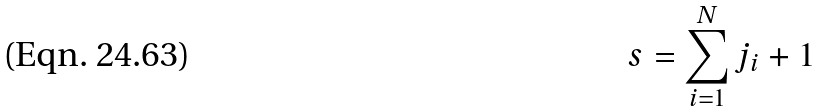<formula> <loc_0><loc_0><loc_500><loc_500>s = \sum _ { i = 1 } ^ { N } j _ { i } + 1</formula> 